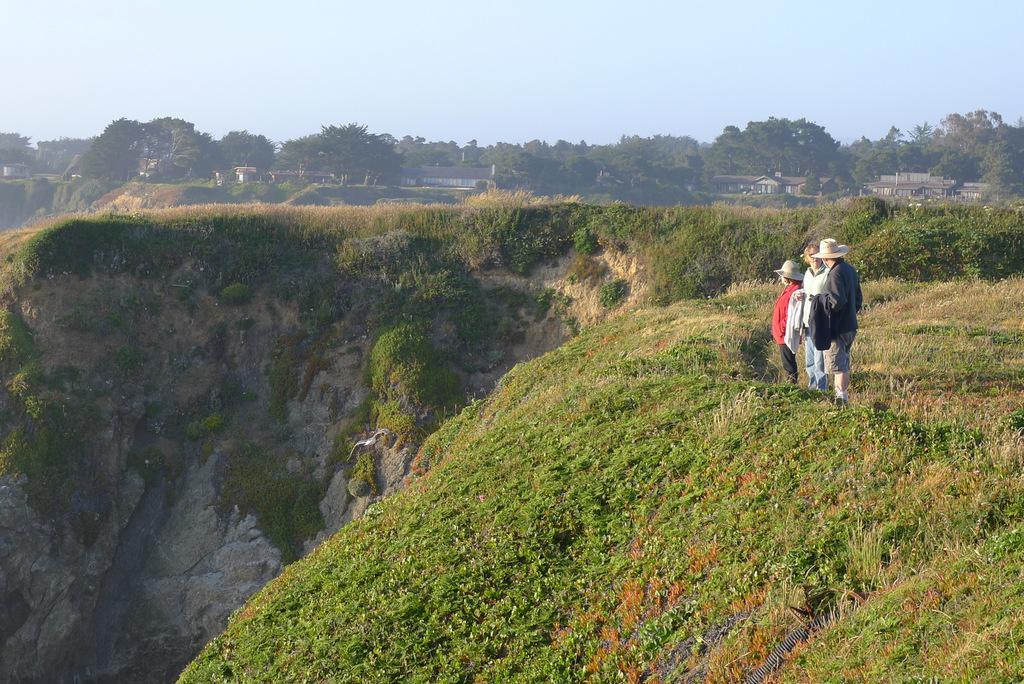Could you give a brief overview of what you see in this image? It is a hill station, three people were standing on the grass beside a valley, the total area is covered with a lot of grass and in the background there are plenty of trees and there are some houses in between. 